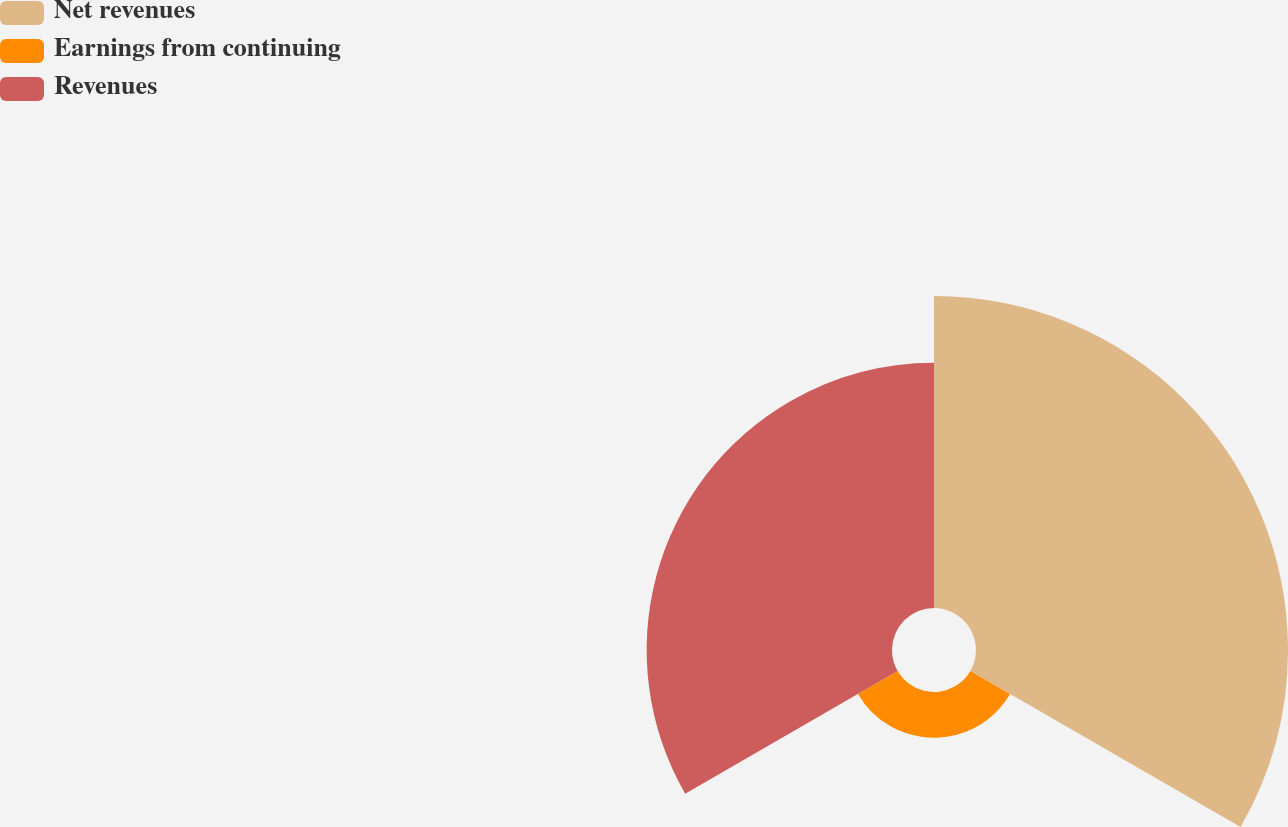Convert chart to OTSL. <chart><loc_0><loc_0><loc_500><loc_500><pie_chart><fcel>Net revenues<fcel>Earnings from continuing<fcel>Revenues<nl><fcel>51.73%<fcel>7.59%<fcel>40.68%<nl></chart> 